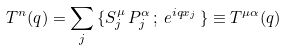<formula> <loc_0><loc_0><loc_500><loc_500>T ^ { n } ( { q } ) = \sum _ { j } \, \{ S _ { j } ^ { \mu } \, P ^ { \alpha } _ { j } \, ; \, e ^ { i q x _ { j } } \, \} \equiv T ^ { \mu \alpha } ( { q } )</formula> 